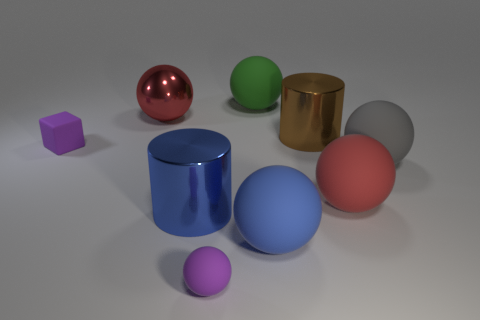Does the cube have the same color as the tiny rubber ball?
Provide a short and direct response. Yes. How many large rubber things are there?
Your response must be concise. 4. The large cylinder that is behind the rubber thing right of the red rubber sphere is made of what material?
Your response must be concise. Metal. What material is the brown cylinder that is the same size as the green rubber ball?
Provide a succinct answer. Metal. There is a metallic cylinder in front of the purple matte block; is it the same size as the purple rubber sphere?
Your response must be concise. No. There is a large blue shiny thing in front of the big green matte thing; is its shape the same as the large red rubber thing?
Provide a succinct answer. No. How many things are either small blue rubber cylinders or big things in front of the red rubber thing?
Provide a succinct answer. 2. Are there fewer yellow things than big blue spheres?
Offer a very short reply. Yes. Is the number of big cylinders greater than the number of shiny blocks?
Your answer should be very brief. Yes. How many other things are the same material as the small cube?
Your answer should be very brief. 5. 